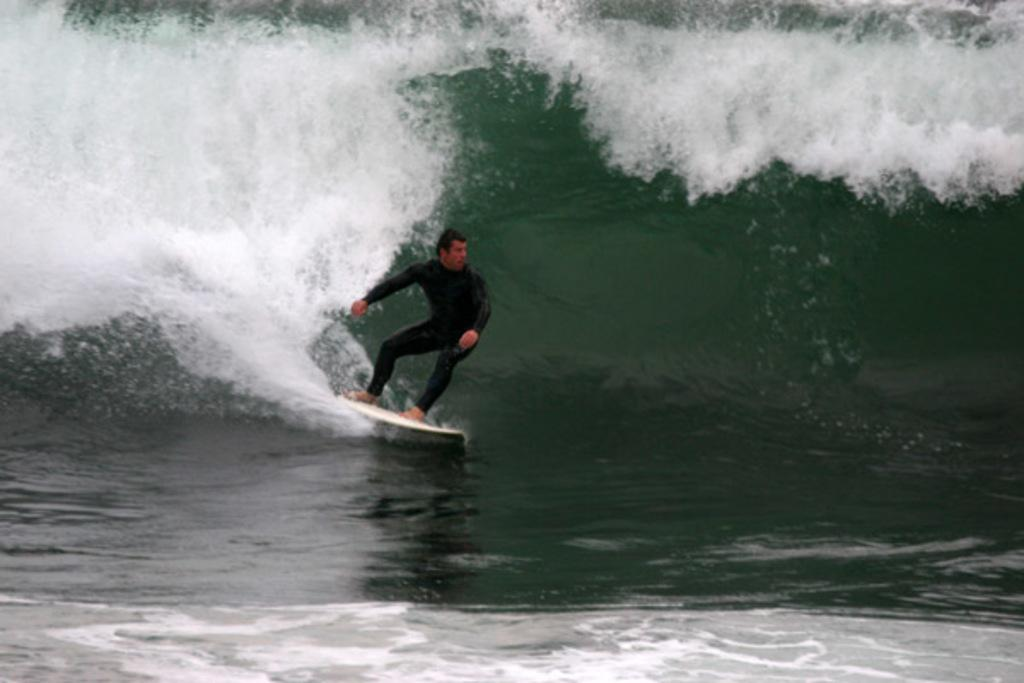Who is the person in the image? There is a man in the image. What is the man doing in the image? The man is surfing in the image. Where is the man surfing? The surfing is taking place on the sea. How does the man sneeze while surfing in the image? There is no indication in the image that the man is sneezing while surfing. 